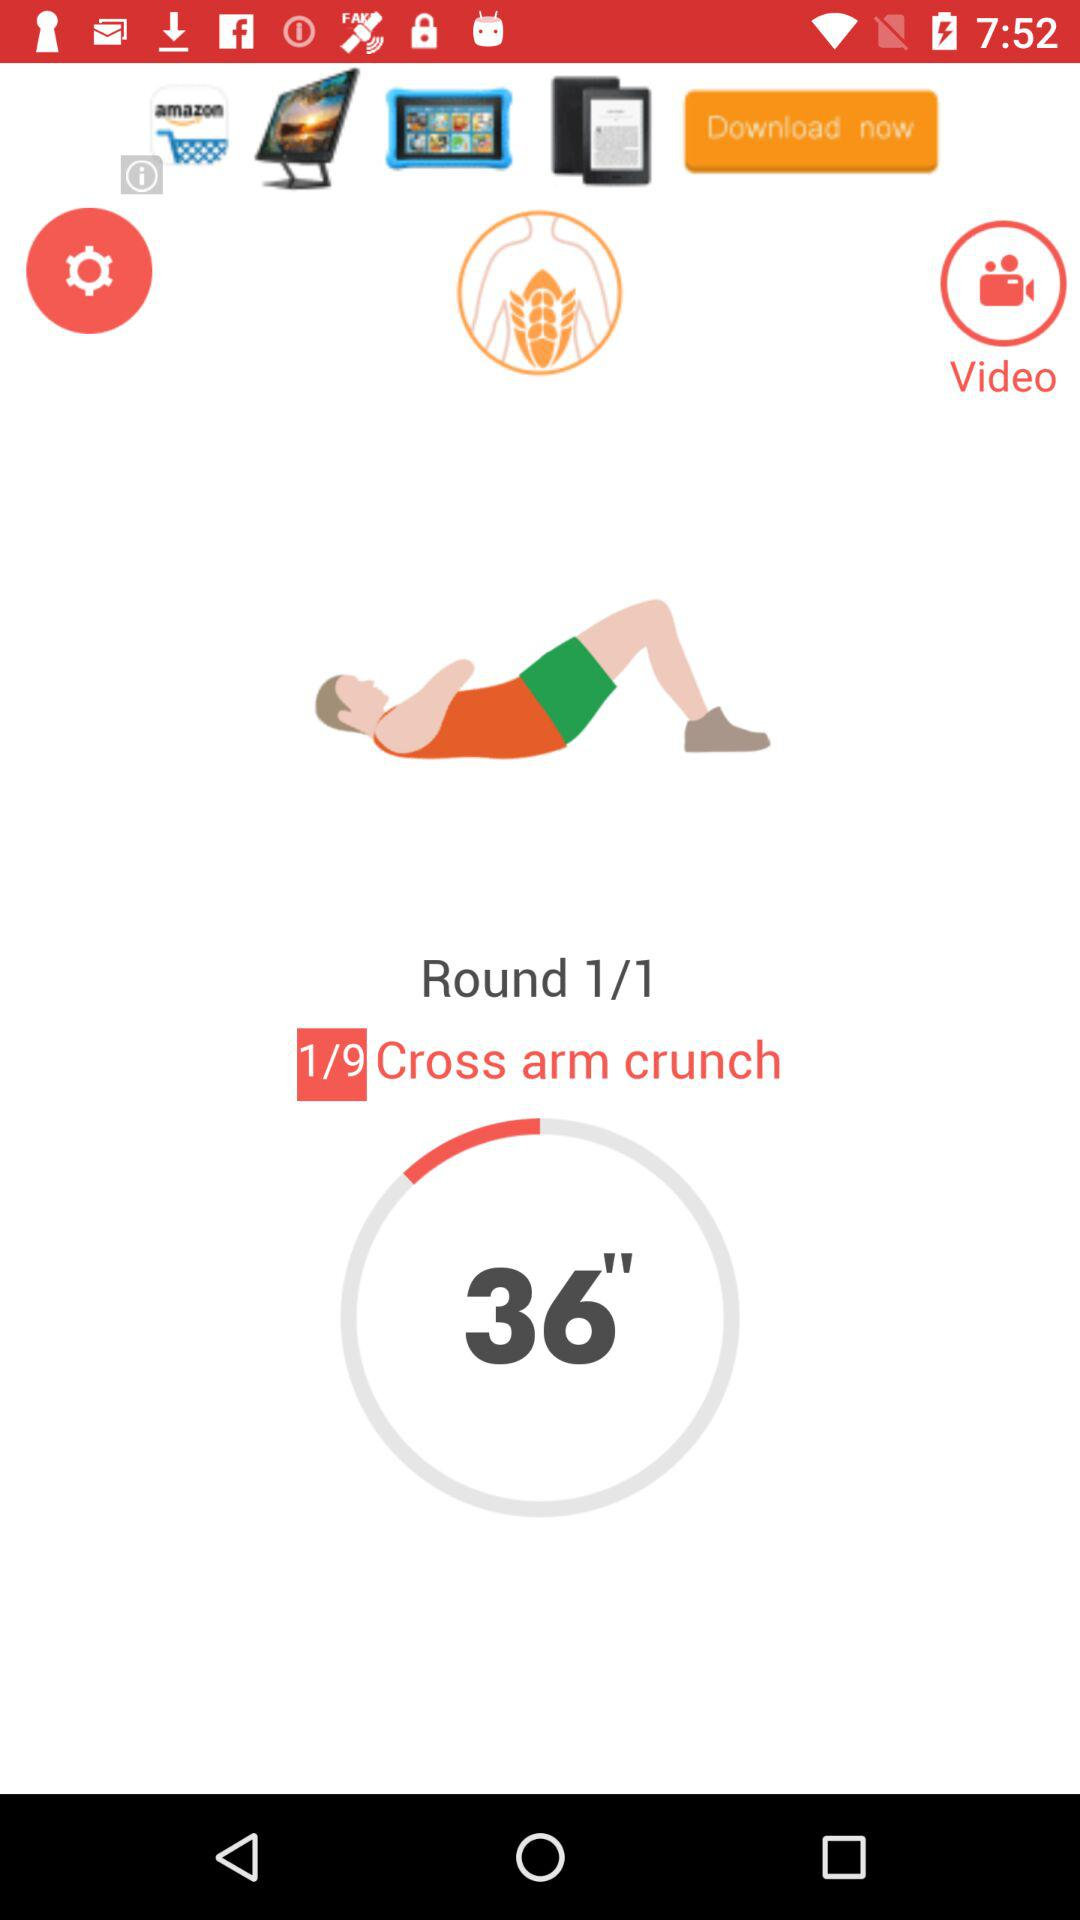How much time is left for the "Cross arm crunch"? The time left is 36". 